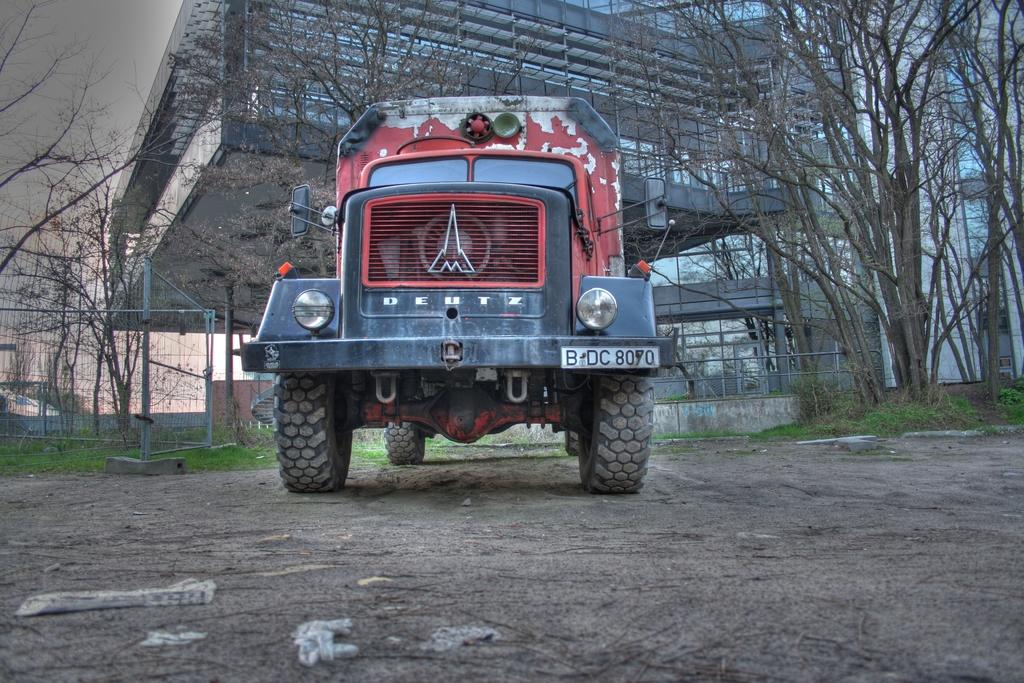What is the main subject of the image? The main subject of the image is a truck. What can be seen on the truck? The truck has a number plate and railings in the back. What can be seen in the background of the image? There are trees, buildings, and the sky visible in the background. What is the ground made of in the image? The ground in the image is covered with grass. Is the truck being used by a spy in the image? There is no indication in the image that the truck is being used by a spy. What type of slope can be seen in the image? There is no slope present in the image; it features a truck with a number plate, railings, and a grassy ground. 